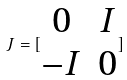<formula> <loc_0><loc_0><loc_500><loc_500>J = [ \begin{matrix} 0 & I \\ - I & 0 \end{matrix} ]</formula> 